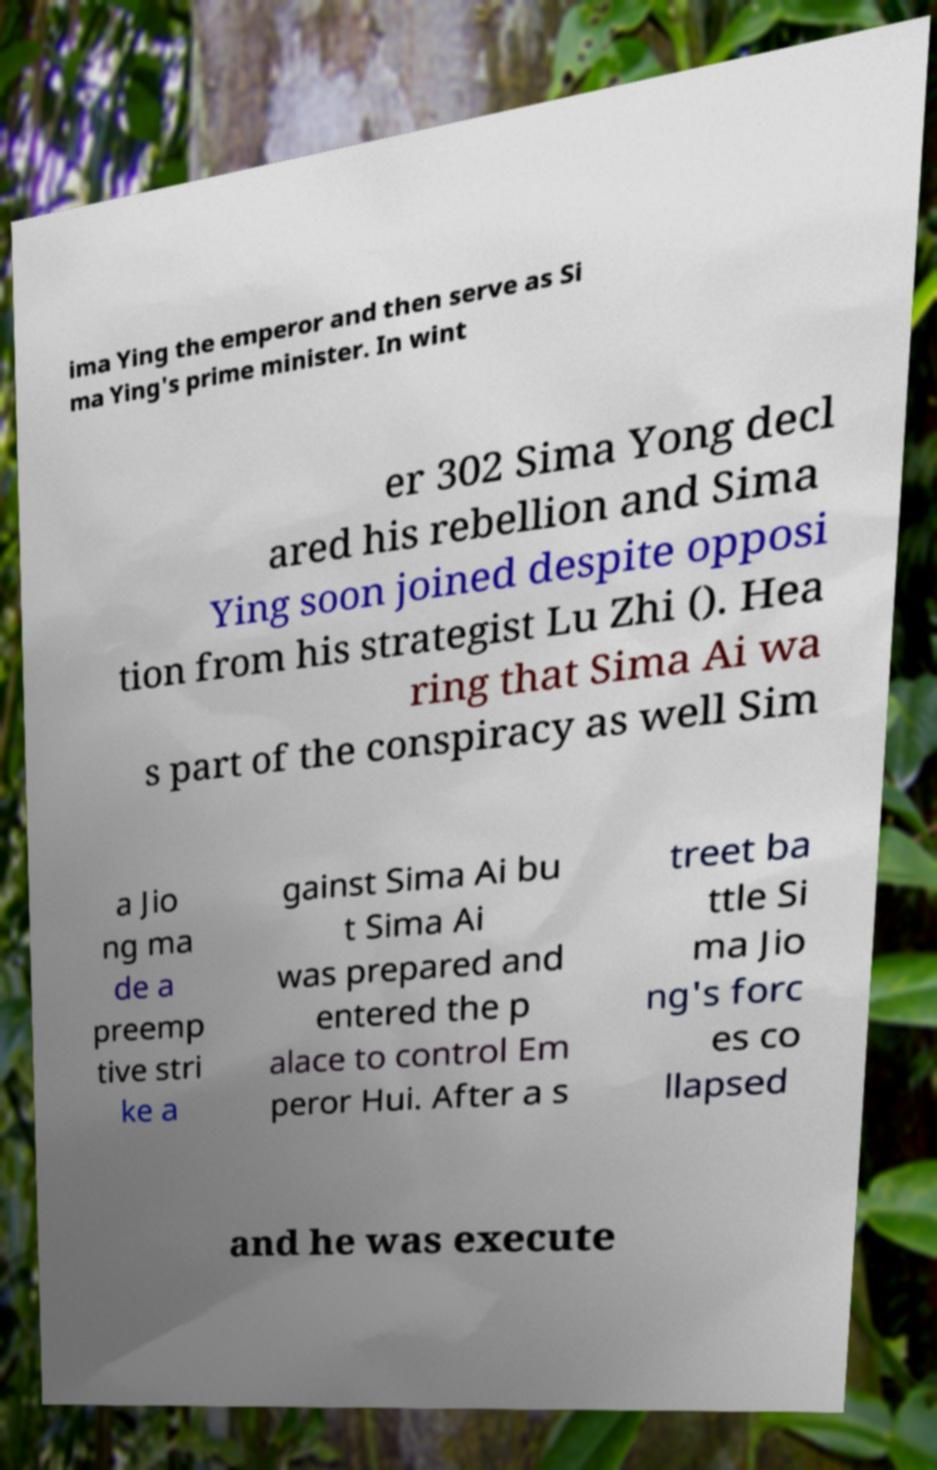Please identify and transcribe the text found in this image. ima Ying the emperor and then serve as Si ma Ying's prime minister. In wint er 302 Sima Yong decl ared his rebellion and Sima Ying soon joined despite opposi tion from his strategist Lu Zhi (). Hea ring that Sima Ai wa s part of the conspiracy as well Sim a Jio ng ma de a preemp tive stri ke a gainst Sima Ai bu t Sima Ai was prepared and entered the p alace to control Em peror Hui. After a s treet ba ttle Si ma Jio ng's forc es co llapsed and he was execute 